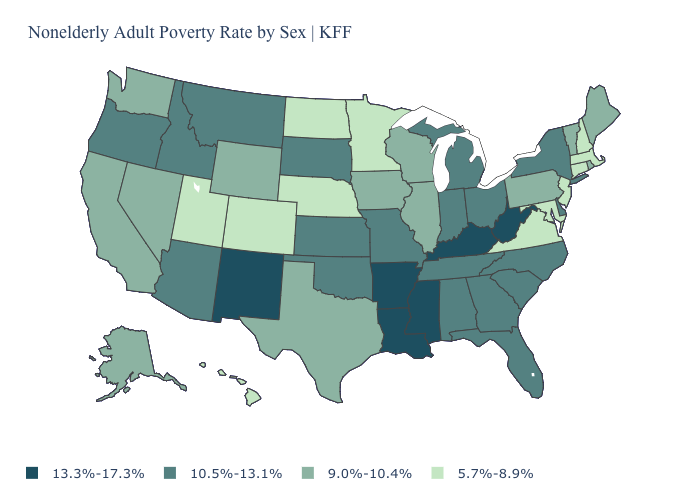Which states have the lowest value in the MidWest?
Short answer required. Minnesota, Nebraska, North Dakota. Which states have the lowest value in the South?
Answer briefly. Maryland, Virginia. What is the value of Florida?
Short answer required. 10.5%-13.1%. What is the value of Wyoming?
Keep it brief. 9.0%-10.4%. Name the states that have a value in the range 13.3%-17.3%?
Answer briefly. Arkansas, Kentucky, Louisiana, Mississippi, New Mexico, West Virginia. Name the states that have a value in the range 13.3%-17.3%?
Quick response, please. Arkansas, Kentucky, Louisiana, Mississippi, New Mexico, West Virginia. Is the legend a continuous bar?
Short answer required. No. Does New York have a lower value than Maine?
Keep it brief. No. Name the states that have a value in the range 13.3%-17.3%?
Write a very short answer. Arkansas, Kentucky, Louisiana, Mississippi, New Mexico, West Virginia. Does Mississippi have the highest value in the USA?
Keep it brief. Yes. What is the lowest value in the MidWest?
Write a very short answer. 5.7%-8.9%. How many symbols are there in the legend?
Write a very short answer. 4. Name the states that have a value in the range 9.0%-10.4%?
Keep it brief. Alaska, California, Illinois, Iowa, Maine, Nevada, Pennsylvania, Rhode Island, Texas, Vermont, Washington, Wisconsin, Wyoming. Among the states that border Oregon , does Idaho have the lowest value?
Keep it brief. No. Name the states that have a value in the range 13.3%-17.3%?
Concise answer only. Arkansas, Kentucky, Louisiana, Mississippi, New Mexico, West Virginia. 